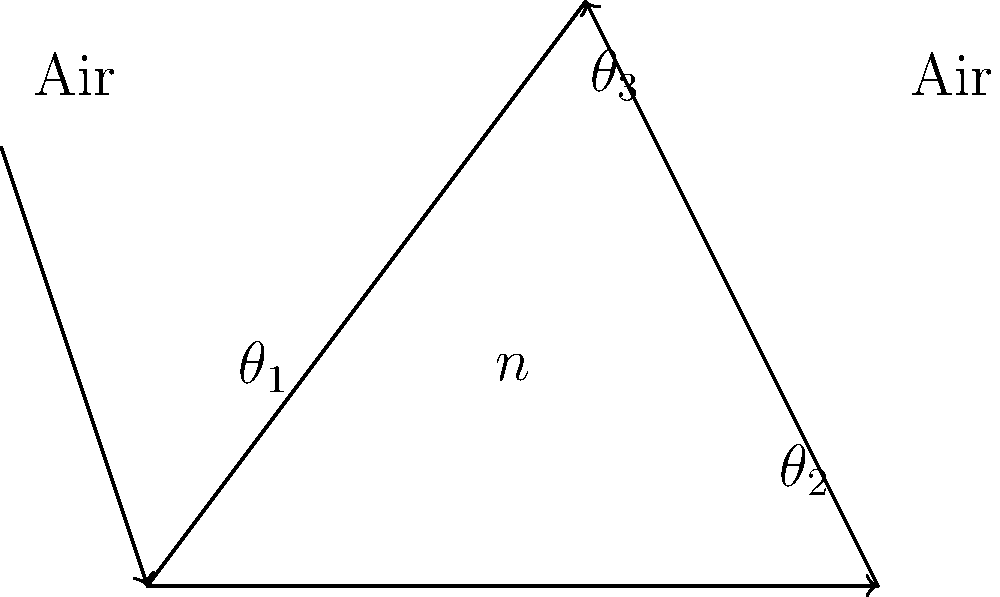A beam of light enters a glass prism with an index of refraction $n = 1.5$ at an angle $\theta_1 = 45°$ to the normal. If the prism has an apex angle of $60°$, calculate the angle $\theta_3$ at which the light emerges from the prism. To solve this problem, we'll follow these steps:

1) First, use Snell's law to find $\theta_2$:
   $$n_1 \sin \theta_1 = n_2 \sin \theta_2$$
   $$1 \cdot \sin 45° = 1.5 \sin \theta_2$$
   $$\sin \theta_2 = \frac{\sin 45°}{1.5} = 0.4714$$
   $$\theta_2 = \arcsin(0.4714) = 28.13°$$

2) The angle of incidence at the second surface is:
   $$60° - 28.13° = 31.87°$$

3) Use Snell's law again for the light exiting the prism:
   $$n_2 \sin 31.87° = n_1 \sin \theta_3$$
   $$1.5 \sin 31.87° = 1 \sin \theta_3$$
   $$\sin \theta_3 = 1.5 \sin 31.87° = 0.7934$$
   $$\theta_3 = \arcsin(0.7934) = 52.64°$$

Therefore, the light emerges from the prism at an angle of approximately 52.64° to the normal.
Answer: $52.64°$ 